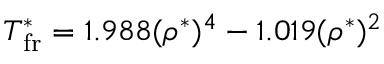<formula> <loc_0><loc_0><loc_500><loc_500>T _ { f r } ^ { * } = 1 . 9 8 8 ( \rho ^ { * } ) ^ { 4 } - 1 . 0 1 9 ( \rho ^ { * } ) ^ { 2 }</formula> 